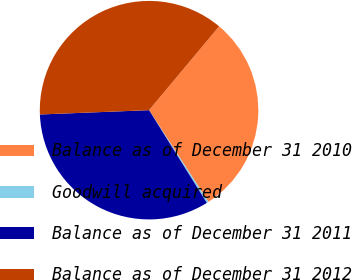Convert chart to OTSL. <chart><loc_0><loc_0><loc_500><loc_500><pie_chart><fcel>Balance as of December 31 2010<fcel>Goodwill acquired<fcel>Balance as of December 31 2011<fcel>Balance as of December 31 2012<nl><fcel>29.77%<fcel>0.28%<fcel>33.24%<fcel>36.71%<nl></chart> 